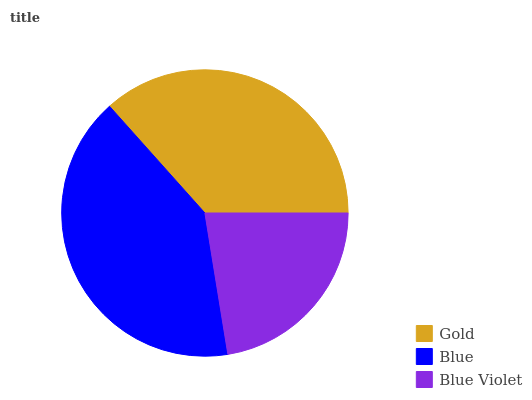Is Blue Violet the minimum?
Answer yes or no. Yes. Is Blue the maximum?
Answer yes or no. Yes. Is Blue the minimum?
Answer yes or no. No. Is Blue Violet the maximum?
Answer yes or no. No. Is Blue greater than Blue Violet?
Answer yes or no. Yes. Is Blue Violet less than Blue?
Answer yes or no. Yes. Is Blue Violet greater than Blue?
Answer yes or no. No. Is Blue less than Blue Violet?
Answer yes or no. No. Is Gold the high median?
Answer yes or no. Yes. Is Gold the low median?
Answer yes or no. Yes. Is Blue Violet the high median?
Answer yes or no. No. Is Blue the low median?
Answer yes or no. No. 